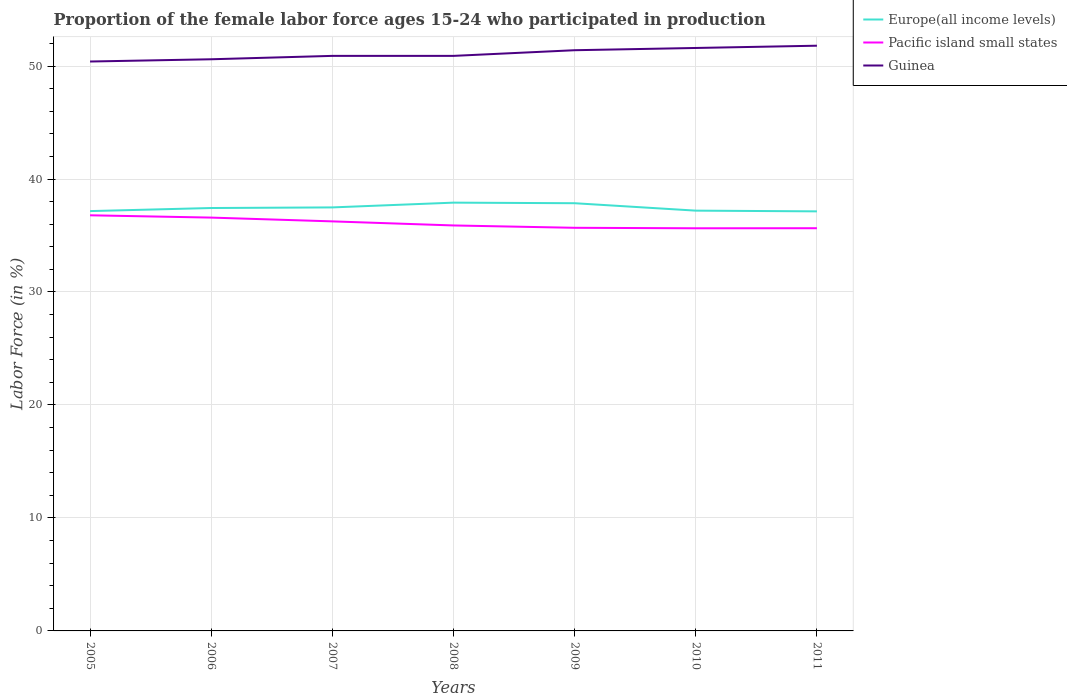How many different coloured lines are there?
Offer a very short reply. 3. Does the line corresponding to Guinea intersect with the line corresponding to Pacific island small states?
Make the answer very short. No. Is the number of lines equal to the number of legend labels?
Your answer should be very brief. Yes. Across all years, what is the maximum proportion of the female labor force who participated in production in Guinea?
Offer a terse response. 50.4. What is the total proportion of the female labor force who participated in production in Europe(all income levels) in the graph?
Provide a succinct answer. 0.71. What is the difference between the highest and the second highest proportion of the female labor force who participated in production in Guinea?
Offer a very short reply. 1.4. What is the difference between the highest and the lowest proportion of the female labor force who participated in production in Europe(all income levels)?
Ensure brevity in your answer.  3. How many lines are there?
Your answer should be very brief. 3. How many years are there in the graph?
Your answer should be very brief. 7. Are the values on the major ticks of Y-axis written in scientific E-notation?
Keep it short and to the point. No. Does the graph contain any zero values?
Provide a succinct answer. No. Does the graph contain grids?
Make the answer very short. Yes. How many legend labels are there?
Keep it short and to the point. 3. How are the legend labels stacked?
Offer a very short reply. Vertical. What is the title of the graph?
Provide a succinct answer. Proportion of the female labor force ages 15-24 who participated in production. Does "Cyprus" appear as one of the legend labels in the graph?
Give a very brief answer. No. What is the label or title of the X-axis?
Make the answer very short. Years. What is the label or title of the Y-axis?
Offer a very short reply. Labor Force (in %). What is the Labor Force (in %) of Europe(all income levels) in 2005?
Provide a succinct answer. 37.16. What is the Labor Force (in %) in Pacific island small states in 2005?
Your answer should be very brief. 36.79. What is the Labor Force (in %) of Guinea in 2005?
Give a very brief answer. 50.4. What is the Labor Force (in %) of Europe(all income levels) in 2006?
Provide a short and direct response. 37.43. What is the Labor Force (in %) in Pacific island small states in 2006?
Ensure brevity in your answer.  36.59. What is the Labor Force (in %) in Guinea in 2006?
Offer a very short reply. 50.6. What is the Labor Force (in %) in Europe(all income levels) in 2007?
Provide a succinct answer. 37.49. What is the Labor Force (in %) in Pacific island small states in 2007?
Ensure brevity in your answer.  36.25. What is the Labor Force (in %) in Guinea in 2007?
Offer a very short reply. 50.9. What is the Labor Force (in %) in Europe(all income levels) in 2008?
Offer a terse response. 37.91. What is the Labor Force (in %) of Pacific island small states in 2008?
Your answer should be very brief. 35.89. What is the Labor Force (in %) in Guinea in 2008?
Make the answer very short. 50.9. What is the Labor Force (in %) in Europe(all income levels) in 2009?
Provide a succinct answer. 37.86. What is the Labor Force (in %) of Pacific island small states in 2009?
Keep it short and to the point. 35.68. What is the Labor Force (in %) in Guinea in 2009?
Provide a short and direct response. 51.4. What is the Labor Force (in %) in Europe(all income levels) in 2010?
Keep it short and to the point. 37.2. What is the Labor Force (in %) of Pacific island small states in 2010?
Provide a succinct answer. 35.64. What is the Labor Force (in %) in Guinea in 2010?
Provide a short and direct response. 51.6. What is the Labor Force (in %) in Europe(all income levels) in 2011?
Give a very brief answer. 37.14. What is the Labor Force (in %) in Pacific island small states in 2011?
Offer a very short reply. 35.64. What is the Labor Force (in %) in Guinea in 2011?
Offer a very short reply. 51.8. Across all years, what is the maximum Labor Force (in %) of Europe(all income levels)?
Make the answer very short. 37.91. Across all years, what is the maximum Labor Force (in %) in Pacific island small states?
Keep it short and to the point. 36.79. Across all years, what is the maximum Labor Force (in %) of Guinea?
Give a very brief answer. 51.8. Across all years, what is the minimum Labor Force (in %) of Europe(all income levels)?
Offer a terse response. 37.14. Across all years, what is the minimum Labor Force (in %) in Pacific island small states?
Provide a short and direct response. 35.64. Across all years, what is the minimum Labor Force (in %) of Guinea?
Ensure brevity in your answer.  50.4. What is the total Labor Force (in %) in Europe(all income levels) in the graph?
Provide a succinct answer. 262.19. What is the total Labor Force (in %) in Pacific island small states in the graph?
Ensure brevity in your answer.  252.48. What is the total Labor Force (in %) of Guinea in the graph?
Provide a succinct answer. 357.6. What is the difference between the Labor Force (in %) of Europe(all income levels) in 2005 and that in 2006?
Your answer should be very brief. -0.27. What is the difference between the Labor Force (in %) of Pacific island small states in 2005 and that in 2006?
Make the answer very short. 0.2. What is the difference between the Labor Force (in %) in Guinea in 2005 and that in 2006?
Ensure brevity in your answer.  -0.2. What is the difference between the Labor Force (in %) in Europe(all income levels) in 2005 and that in 2007?
Provide a short and direct response. -0.33. What is the difference between the Labor Force (in %) of Pacific island small states in 2005 and that in 2007?
Offer a terse response. 0.54. What is the difference between the Labor Force (in %) in Guinea in 2005 and that in 2007?
Make the answer very short. -0.5. What is the difference between the Labor Force (in %) in Europe(all income levels) in 2005 and that in 2008?
Your answer should be very brief. -0.75. What is the difference between the Labor Force (in %) of Pacific island small states in 2005 and that in 2008?
Provide a succinct answer. 0.9. What is the difference between the Labor Force (in %) in Europe(all income levels) in 2005 and that in 2009?
Ensure brevity in your answer.  -0.7. What is the difference between the Labor Force (in %) in Pacific island small states in 2005 and that in 2009?
Make the answer very short. 1.11. What is the difference between the Labor Force (in %) in Europe(all income levels) in 2005 and that in 2010?
Give a very brief answer. -0.04. What is the difference between the Labor Force (in %) of Pacific island small states in 2005 and that in 2010?
Your answer should be compact. 1.15. What is the difference between the Labor Force (in %) of Europe(all income levels) in 2005 and that in 2011?
Give a very brief answer. 0.02. What is the difference between the Labor Force (in %) of Pacific island small states in 2005 and that in 2011?
Your response must be concise. 1.14. What is the difference between the Labor Force (in %) of Guinea in 2005 and that in 2011?
Your answer should be compact. -1.4. What is the difference between the Labor Force (in %) of Europe(all income levels) in 2006 and that in 2007?
Offer a very short reply. -0.05. What is the difference between the Labor Force (in %) in Pacific island small states in 2006 and that in 2007?
Keep it short and to the point. 0.33. What is the difference between the Labor Force (in %) in Europe(all income levels) in 2006 and that in 2008?
Your response must be concise. -0.48. What is the difference between the Labor Force (in %) in Pacific island small states in 2006 and that in 2008?
Offer a very short reply. 0.7. What is the difference between the Labor Force (in %) in Europe(all income levels) in 2006 and that in 2009?
Your answer should be compact. -0.43. What is the difference between the Labor Force (in %) in Pacific island small states in 2006 and that in 2009?
Provide a short and direct response. 0.9. What is the difference between the Labor Force (in %) of Europe(all income levels) in 2006 and that in 2010?
Make the answer very short. 0.23. What is the difference between the Labor Force (in %) in Pacific island small states in 2006 and that in 2010?
Offer a very short reply. 0.95. What is the difference between the Labor Force (in %) of Guinea in 2006 and that in 2010?
Give a very brief answer. -1. What is the difference between the Labor Force (in %) in Europe(all income levels) in 2006 and that in 2011?
Your response must be concise. 0.3. What is the difference between the Labor Force (in %) of Pacific island small states in 2006 and that in 2011?
Provide a succinct answer. 0.94. What is the difference between the Labor Force (in %) of Europe(all income levels) in 2007 and that in 2008?
Provide a short and direct response. -0.42. What is the difference between the Labor Force (in %) in Pacific island small states in 2007 and that in 2008?
Offer a very short reply. 0.36. What is the difference between the Labor Force (in %) of Guinea in 2007 and that in 2008?
Provide a succinct answer. 0. What is the difference between the Labor Force (in %) of Europe(all income levels) in 2007 and that in 2009?
Provide a succinct answer. -0.37. What is the difference between the Labor Force (in %) in Pacific island small states in 2007 and that in 2009?
Keep it short and to the point. 0.57. What is the difference between the Labor Force (in %) of Guinea in 2007 and that in 2009?
Give a very brief answer. -0.5. What is the difference between the Labor Force (in %) in Europe(all income levels) in 2007 and that in 2010?
Provide a succinct answer. 0.29. What is the difference between the Labor Force (in %) in Pacific island small states in 2007 and that in 2010?
Offer a very short reply. 0.61. What is the difference between the Labor Force (in %) in Guinea in 2007 and that in 2010?
Give a very brief answer. -0.7. What is the difference between the Labor Force (in %) of Europe(all income levels) in 2007 and that in 2011?
Give a very brief answer. 0.35. What is the difference between the Labor Force (in %) of Pacific island small states in 2007 and that in 2011?
Give a very brief answer. 0.61. What is the difference between the Labor Force (in %) of Guinea in 2007 and that in 2011?
Offer a terse response. -0.9. What is the difference between the Labor Force (in %) of Europe(all income levels) in 2008 and that in 2009?
Offer a very short reply. 0.05. What is the difference between the Labor Force (in %) of Pacific island small states in 2008 and that in 2009?
Offer a very short reply. 0.21. What is the difference between the Labor Force (in %) in Europe(all income levels) in 2008 and that in 2010?
Give a very brief answer. 0.71. What is the difference between the Labor Force (in %) in Pacific island small states in 2008 and that in 2010?
Ensure brevity in your answer.  0.25. What is the difference between the Labor Force (in %) in Europe(all income levels) in 2008 and that in 2011?
Give a very brief answer. 0.77. What is the difference between the Labor Force (in %) of Pacific island small states in 2008 and that in 2011?
Your answer should be compact. 0.25. What is the difference between the Labor Force (in %) in Guinea in 2008 and that in 2011?
Keep it short and to the point. -0.9. What is the difference between the Labor Force (in %) in Europe(all income levels) in 2009 and that in 2010?
Provide a short and direct response. 0.66. What is the difference between the Labor Force (in %) in Pacific island small states in 2009 and that in 2010?
Offer a terse response. 0.04. What is the difference between the Labor Force (in %) of Europe(all income levels) in 2009 and that in 2011?
Your answer should be very brief. 0.72. What is the difference between the Labor Force (in %) of Pacific island small states in 2009 and that in 2011?
Your answer should be compact. 0.04. What is the difference between the Labor Force (in %) of Europe(all income levels) in 2010 and that in 2011?
Make the answer very short. 0.06. What is the difference between the Labor Force (in %) in Pacific island small states in 2010 and that in 2011?
Provide a short and direct response. -0.01. What is the difference between the Labor Force (in %) in Guinea in 2010 and that in 2011?
Make the answer very short. -0.2. What is the difference between the Labor Force (in %) in Europe(all income levels) in 2005 and the Labor Force (in %) in Pacific island small states in 2006?
Provide a short and direct response. 0.58. What is the difference between the Labor Force (in %) of Europe(all income levels) in 2005 and the Labor Force (in %) of Guinea in 2006?
Provide a short and direct response. -13.44. What is the difference between the Labor Force (in %) in Pacific island small states in 2005 and the Labor Force (in %) in Guinea in 2006?
Make the answer very short. -13.81. What is the difference between the Labor Force (in %) of Europe(all income levels) in 2005 and the Labor Force (in %) of Pacific island small states in 2007?
Give a very brief answer. 0.91. What is the difference between the Labor Force (in %) of Europe(all income levels) in 2005 and the Labor Force (in %) of Guinea in 2007?
Make the answer very short. -13.74. What is the difference between the Labor Force (in %) of Pacific island small states in 2005 and the Labor Force (in %) of Guinea in 2007?
Keep it short and to the point. -14.11. What is the difference between the Labor Force (in %) in Europe(all income levels) in 2005 and the Labor Force (in %) in Pacific island small states in 2008?
Make the answer very short. 1.27. What is the difference between the Labor Force (in %) of Europe(all income levels) in 2005 and the Labor Force (in %) of Guinea in 2008?
Offer a terse response. -13.74. What is the difference between the Labor Force (in %) of Pacific island small states in 2005 and the Labor Force (in %) of Guinea in 2008?
Offer a terse response. -14.11. What is the difference between the Labor Force (in %) in Europe(all income levels) in 2005 and the Labor Force (in %) in Pacific island small states in 2009?
Offer a very short reply. 1.48. What is the difference between the Labor Force (in %) of Europe(all income levels) in 2005 and the Labor Force (in %) of Guinea in 2009?
Offer a very short reply. -14.24. What is the difference between the Labor Force (in %) in Pacific island small states in 2005 and the Labor Force (in %) in Guinea in 2009?
Your answer should be very brief. -14.61. What is the difference between the Labor Force (in %) in Europe(all income levels) in 2005 and the Labor Force (in %) in Pacific island small states in 2010?
Make the answer very short. 1.52. What is the difference between the Labor Force (in %) of Europe(all income levels) in 2005 and the Labor Force (in %) of Guinea in 2010?
Provide a succinct answer. -14.44. What is the difference between the Labor Force (in %) of Pacific island small states in 2005 and the Labor Force (in %) of Guinea in 2010?
Your answer should be compact. -14.81. What is the difference between the Labor Force (in %) of Europe(all income levels) in 2005 and the Labor Force (in %) of Pacific island small states in 2011?
Give a very brief answer. 1.52. What is the difference between the Labor Force (in %) in Europe(all income levels) in 2005 and the Labor Force (in %) in Guinea in 2011?
Make the answer very short. -14.64. What is the difference between the Labor Force (in %) of Pacific island small states in 2005 and the Labor Force (in %) of Guinea in 2011?
Provide a succinct answer. -15.01. What is the difference between the Labor Force (in %) of Europe(all income levels) in 2006 and the Labor Force (in %) of Pacific island small states in 2007?
Ensure brevity in your answer.  1.18. What is the difference between the Labor Force (in %) of Europe(all income levels) in 2006 and the Labor Force (in %) of Guinea in 2007?
Make the answer very short. -13.47. What is the difference between the Labor Force (in %) in Pacific island small states in 2006 and the Labor Force (in %) in Guinea in 2007?
Give a very brief answer. -14.31. What is the difference between the Labor Force (in %) in Europe(all income levels) in 2006 and the Labor Force (in %) in Pacific island small states in 2008?
Offer a very short reply. 1.54. What is the difference between the Labor Force (in %) of Europe(all income levels) in 2006 and the Labor Force (in %) of Guinea in 2008?
Make the answer very short. -13.47. What is the difference between the Labor Force (in %) in Pacific island small states in 2006 and the Labor Force (in %) in Guinea in 2008?
Provide a short and direct response. -14.31. What is the difference between the Labor Force (in %) of Europe(all income levels) in 2006 and the Labor Force (in %) of Pacific island small states in 2009?
Offer a terse response. 1.75. What is the difference between the Labor Force (in %) in Europe(all income levels) in 2006 and the Labor Force (in %) in Guinea in 2009?
Offer a very short reply. -13.97. What is the difference between the Labor Force (in %) in Pacific island small states in 2006 and the Labor Force (in %) in Guinea in 2009?
Keep it short and to the point. -14.81. What is the difference between the Labor Force (in %) of Europe(all income levels) in 2006 and the Labor Force (in %) of Pacific island small states in 2010?
Provide a short and direct response. 1.79. What is the difference between the Labor Force (in %) of Europe(all income levels) in 2006 and the Labor Force (in %) of Guinea in 2010?
Ensure brevity in your answer.  -14.17. What is the difference between the Labor Force (in %) of Pacific island small states in 2006 and the Labor Force (in %) of Guinea in 2010?
Give a very brief answer. -15.01. What is the difference between the Labor Force (in %) in Europe(all income levels) in 2006 and the Labor Force (in %) in Pacific island small states in 2011?
Make the answer very short. 1.79. What is the difference between the Labor Force (in %) in Europe(all income levels) in 2006 and the Labor Force (in %) in Guinea in 2011?
Your response must be concise. -14.37. What is the difference between the Labor Force (in %) in Pacific island small states in 2006 and the Labor Force (in %) in Guinea in 2011?
Make the answer very short. -15.21. What is the difference between the Labor Force (in %) in Europe(all income levels) in 2007 and the Labor Force (in %) in Pacific island small states in 2008?
Give a very brief answer. 1.6. What is the difference between the Labor Force (in %) in Europe(all income levels) in 2007 and the Labor Force (in %) in Guinea in 2008?
Your answer should be very brief. -13.41. What is the difference between the Labor Force (in %) in Pacific island small states in 2007 and the Labor Force (in %) in Guinea in 2008?
Your answer should be very brief. -14.65. What is the difference between the Labor Force (in %) in Europe(all income levels) in 2007 and the Labor Force (in %) in Pacific island small states in 2009?
Your answer should be very brief. 1.81. What is the difference between the Labor Force (in %) in Europe(all income levels) in 2007 and the Labor Force (in %) in Guinea in 2009?
Provide a succinct answer. -13.91. What is the difference between the Labor Force (in %) in Pacific island small states in 2007 and the Labor Force (in %) in Guinea in 2009?
Offer a terse response. -15.15. What is the difference between the Labor Force (in %) in Europe(all income levels) in 2007 and the Labor Force (in %) in Pacific island small states in 2010?
Make the answer very short. 1.85. What is the difference between the Labor Force (in %) in Europe(all income levels) in 2007 and the Labor Force (in %) in Guinea in 2010?
Make the answer very short. -14.11. What is the difference between the Labor Force (in %) in Pacific island small states in 2007 and the Labor Force (in %) in Guinea in 2010?
Provide a short and direct response. -15.35. What is the difference between the Labor Force (in %) of Europe(all income levels) in 2007 and the Labor Force (in %) of Pacific island small states in 2011?
Your answer should be compact. 1.84. What is the difference between the Labor Force (in %) of Europe(all income levels) in 2007 and the Labor Force (in %) of Guinea in 2011?
Keep it short and to the point. -14.31. What is the difference between the Labor Force (in %) of Pacific island small states in 2007 and the Labor Force (in %) of Guinea in 2011?
Offer a very short reply. -15.55. What is the difference between the Labor Force (in %) in Europe(all income levels) in 2008 and the Labor Force (in %) in Pacific island small states in 2009?
Your answer should be compact. 2.23. What is the difference between the Labor Force (in %) of Europe(all income levels) in 2008 and the Labor Force (in %) of Guinea in 2009?
Offer a very short reply. -13.49. What is the difference between the Labor Force (in %) in Pacific island small states in 2008 and the Labor Force (in %) in Guinea in 2009?
Give a very brief answer. -15.51. What is the difference between the Labor Force (in %) of Europe(all income levels) in 2008 and the Labor Force (in %) of Pacific island small states in 2010?
Make the answer very short. 2.27. What is the difference between the Labor Force (in %) in Europe(all income levels) in 2008 and the Labor Force (in %) in Guinea in 2010?
Provide a short and direct response. -13.69. What is the difference between the Labor Force (in %) in Pacific island small states in 2008 and the Labor Force (in %) in Guinea in 2010?
Keep it short and to the point. -15.71. What is the difference between the Labor Force (in %) of Europe(all income levels) in 2008 and the Labor Force (in %) of Pacific island small states in 2011?
Ensure brevity in your answer.  2.26. What is the difference between the Labor Force (in %) of Europe(all income levels) in 2008 and the Labor Force (in %) of Guinea in 2011?
Make the answer very short. -13.89. What is the difference between the Labor Force (in %) of Pacific island small states in 2008 and the Labor Force (in %) of Guinea in 2011?
Offer a terse response. -15.91. What is the difference between the Labor Force (in %) in Europe(all income levels) in 2009 and the Labor Force (in %) in Pacific island small states in 2010?
Provide a succinct answer. 2.22. What is the difference between the Labor Force (in %) in Europe(all income levels) in 2009 and the Labor Force (in %) in Guinea in 2010?
Give a very brief answer. -13.74. What is the difference between the Labor Force (in %) of Pacific island small states in 2009 and the Labor Force (in %) of Guinea in 2010?
Provide a short and direct response. -15.92. What is the difference between the Labor Force (in %) in Europe(all income levels) in 2009 and the Labor Force (in %) in Pacific island small states in 2011?
Your answer should be compact. 2.21. What is the difference between the Labor Force (in %) of Europe(all income levels) in 2009 and the Labor Force (in %) of Guinea in 2011?
Provide a short and direct response. -13.94. What is the difference between the Labor Force (in %) of Pacific island small states in 2009 and the Labor Force (in %) of Guinea in 2011?
Provide a short and direct response. -16.12. What is the difference between the Labor Force (in %) in Europe(all income levels) in 2010 and the Labor Force (in %) in Pacific island small states in 2011?
Provide a short and direct response. 1.56. What is the difference between the Labor Force (in %) of Europe(all income levels) in 2010 and the Labor Force (in %) of Guinea in 2011?
Give a very brief answer. -14.6. What is the difference between the Labor Force (in %) of Pacific island small states in 2010 and the Labor Force (in %) of Guinea in 2011?
Ensure brevity in your answer.  -16.16. What is the average Labor Force (in %) in Europe(all income levels) per year?
Give a very brief answer. 37.46. What is the average Labor Force (in %) of Pacific island small states per year?
Provide a short and direct response. 36.07. What is the average Labor Force (in %) of Guinea per year?
Offer a very short reply. 51.09. In the year 2005, what is the difference between the Labor Force (in %) of Europe(all income levels) and Labor Force (in %) of Pacific island small states?
Your response must be concise. 0.37. In the year 2005, what is the difference between the Labor Force (in %) in Europe(all income levels) and Labor Force (in %) in Guinea?
Keep it short and to the point. -13.24. In the year 2005, what is the difference between the Labor Force (in %) in Pacific island small states and Labor Force (in %) in Guinea?
Ensure brevity in your answer.  -13.61. In the year 2006, what is the difference between the Labor Force (in %) of Europe(all income levels) and Labor Force (in %) of Pacific island small states?
Your answer should be compact. 0.85. In the year 2006, what is the difference between the Labor Force (in %) of Europe(all income levels) and Labor Force (in %) of Guinea?
Ensure brevity in your answer.  -13.17. In the year 2006, what is the difference between the Labor Force (in %) in Pacific island small states and Labor Force (in %) in Guinea?
Provide a succinct answer. -14.01. In the year 2007, what is the difference between the Labor Force (in %) in Europe(all income levels) and Labor Force (in %) in Pacific island small states?
Your answer should be very brief. 1.24. In the year 2007, what is the difference between the Labor Force (in %) in Europe(all income levels) and Labor Force (in %) in Guinea?
Give a very brief answer. -13.41. In the year 2007, what is the difference between the Labor Force (in %) in Pacific island small states and Labor Force (in %) in Guinea?
Keep it short and to the point. -14.65. In the year 2008, what is the difference between the Labor Force (in %) in Europe(all income levels) and Labor Force (in %) in Pacific island small states?
Offer a terse response. 2.02. In the year 2008, what is the difference between the Labor Force (in %) of Europe(all income levels) and Labor Force (in %) of Guinea?
Ensure brevity in your answer.  -12.99. In the year 2008, what is the difference between the Labor Force (in %) of Pacific island small states and Labor Force (in %) of Guinea?
Make the answer very short. -15.01. In the year 2009, what is the difference between the Labor Force (in %) in Europe(all income levels) and Labor Force (in %) in Pacific island small states?
Ensure brevity in your answer.  2.18. In the year 2009, what is the difference between the Labor Force (in %) of Europe(all income levels) and Labor Force (in %) of Guinea?
Make the answer very short. -13.54. In the year 2009, what is the difference between the Labor Force (in %) in Pacific island small states and Labor Force (in %) in Guinea?
Offer a very short reply. -15.72. In the year 2010, what is the difference between the Labor Force (in %) in Europe(all income levels) and Labor Force (in %) in Pacific island small states?
Keep it short and to the point. 1.56. In the year 2010, what is the difference between the Labor Force (in %) in Europe(all income levels) and Labor Force (in %) in Guinea?
Provide a succinct answer. -14.4. In the year 2010, what is the difference between the Labor Force (in %) of Pacific island small states and Labor Force (in %) of Guinea?
Offer a very short reply. -15.96. In the year 2011, what is the difference between the Labor Force (in %) of Europe(all income levels) and Labor Force (in %) of Pacific island small states?
Keep it short and to the point. 1.49. In the year 2011, what is the difference between the Labor Force (in %) in Europe(all income levels) and Labor Force (in %) in Guinea?
Offer a very short reply. -14.66. In the year 2011, what is the difference between the Labor Force (in %) in Pacific island small states and Labor Force (in %) in Guinea?
Offer a terse response. -16.16. What is the ratio of the Labor Force (in %) of Europe(all income levels) in 2005 to that in 2006?
Your answer should be compact. 0.99. What is the ratio of the Labor Force (in %) of Pacific island small states in 2005 to that in 2006?
Your response must be concise. 1.01. What is the ratio of the Labor Force (in %) in Guinea in 2005 to that in 2006?
Make the answer very short. 1. What is the ratio of the Labor Force (in %) in Europe(all income levels) in 2005 to that in 2007?
Provide a succinct answer. 0.99. What is the ratio of the Labor Force (in %) in Pacific island small states in 2005 to that in 2007?
Keep it short and to the point. 1.01. What is the ratio of the Labor Force (in %) of Guinea in 2005 to that in 2007?
Give a very brief answer. 0.99. What is the ratio of the Labor Force (in %) of Europe(all income levels) in 2005 to that in 2008?
Your response must be concise. 0.98. What is the ratio of the Labor Force (in %) of Guinea in 2005 to that in 2008?
Make the answer very short. 0.99. What is the ratio of the Labor Force (in %) of Europe(all income levels) in 2005 to that in 2009?
Your answer should be compact. 0.98. What is the ratio of the Labor Force (in %) of Pacific island small states in 2005 to that in 2009?
Make the answer very short. 1.03. What is the ratio of the Labor Force (in %) of Guinea in 2005 to that in 2009?
Provide a succinct answer. 0.98. What is the ratio of the Labor Force (in %) of Europe(all income levels) in 2005 to that in 2010?
Keep it short and to the point. 1. What is the ratio of the Labor Force (in %) of Pacific island small states in 2005 to that in 2010?
Keep it short and to the point. 1.03. What is the ratio of the Labor Force (in %) in Guinea in 2005 to that in 2010?
Make the answer very short. 0.98. What is the ratio of the Labor Force (in %) of Pacific island small states in 2005 to that in 2011?
Your answer should be very brief. 1.03. What is the ratio of the Labor Force (in %) in Guinea in 2005 to that in 2011?
Your response must be concise. 0.97. What is the ratio of the Labor Force (in %) in Europe(all income levels) in 2006 to that in 2007?
Provide a succinct answer. 1. What is the ratio of the Labor Force (in %) in Pacific island small states in 2006 to that in 2007?
Give a very brief answer. 1.01. What is the ratio of the Labor Force (in %) in Guinea in 2006 to that in 2007?
Give a very brief answer. 0.99. What is the ratio of the Labor Force (in %) of Europe(all income levels) in 2006 to that in 2008?
Keep it short and to the point. 0.99. What is the ratio of the Labor Force (in %) in Pacific island small states in 2006 to that in 2008?
Your answer should be very brief. 1.02. What is the ratio of the Labor Force (in %) of Pacific island small states in 2006 to that in 2009?
Your answer should be compact. 1.03. What is the ratio of the Labor Force (in %) in Guinea in 2006 to that in 2009?
Offer a very short reply. 0.98. What is the ratio of the Labor Force (in %) in Europe(all income levels) in 2006 to that in 2010?
Make the answer very short. 1.01. What is the ratio of the Labor Force (in %) of Pacific island small states in 2006 to that in 2010?
Make the answer very short. 1.03. What is the ratio of the Labor Force (in %) of Guinea in 2006 to that in 2010?
Provide a short and direct response. 0.98. What is the ratio of the Labor Force (in %) in Pacific island small states in 2006 to that in 2011?
Provide a short and direct response. 1.03. What is the ratio of the Labor Force (in %) of Guinea in 2006 to that in 2011?
Make the answer very short. 0.98. What is the ratio of the Labor Force (in %) in Europe(all income levels) in 2007 to that in 2008?
Provide a short and direct response. 0.99. What is the ratio of the Labor Force (in %) in Pacific island small states in 2007 to that in 2008?
Your response must be concise. 1.01. What is the ratio of the Labor Force (in %) of Guinea in 2007 to that in 2008?
Your response must be concise. 1. What is the ratio of the Labor Force (in %) in Europe(all income levels) in 2007 to that in 2009?
Offer a terse response. 0.99. What is the ratio of the Labor Force (in %) of Pacific island small states in 2007 to that in 2009?
Provide a short and direct response. 1.02. What is the ratio of the Labor Force (in %) of Guinea in 2007 to that in 2009?
Offer a terse response. 0.99. What is the ratio of the Labor Force (in %) of Europe(all income levels) in 2007 to that in 2010?
Your answer should be very brief. 1.01. What is the ratio of the Labor Force (in %) in Pacific island small states in 2007 to that in 2010?
Offer a very short reply. 1.02. What is the ratio of the Labor Force (in %) of Guinea in 2007 to that in 2010?
Keep it short and to the point. 0.99. What is the ratio of the Labor Force (in %) of Europe(all income levels) in 2007 to that in 2011?
Offer a very short reply. 1.01. What is the ratio of the Labor Force (in %) of Guinea in 2007 to that in 2011?
Offer a very short reply. 0.98. What is the ratio of the Labor Force (in %) in Pacific island small states in 2008 to that in 2009?
Your answer should be compact. 1.01. What is the ratio of the Labor Force (in %) in Guinea in 2008 to that in 2009?
Your response must be concise. 0.99. What is the ratio of the Labor Force (in %) of Europe(all income levels) in 2008 to that in 2010?
Provide a succinct answer. 1.02. What is the ratio of the Labor Force (in %) in Pacific island small states in 2008 to that in 2010?
Offer a terse response. 1.01. What is the ratio of the Labor Force (in %) of Guinea in 2008 to that in 2010?
Your answer should be very brief. 0.99. What is the ratio of the Labor Force (in %) of Europe(all income levels) in 2008 to that in 2011?
Provide a short and direct response. 1.02. What is the ratio of the Labor Force (in %) of Pacific island small states in 2008 to that in 2011?
Ensure brevity in your answer.  1.01. What is the ratio of the Labor Force (in %) in Guinea in 2008 to that in 2011?
Make the answer very short. 0.98. What is the ratio of the Labor Force (in %) in Europe(all income levels) in 2009 to that in 2010?
Keep it short and to the point. 1.02. What is the ratio of the Labor Force (in %) of Pacific island small states in 2009 to that in 2010?
Keep it short and to the point. 1. What is the ratio of the Labor Force (in %) in Europe(all income levels) in 2009 to that in 2011?
Your response must be concise. 1.02. What is the ratio of the Labor Force (in %) in Europe(all income levels) in 2010 to that in 2011?
Make the answer very short. 1. What is the ratio of the Labor Force (in %) in Guinea in 2010 to that in 2011?
Keep it short and to the point. 1. What is the difference between the highest and the second highest Labor Force (in %) in Europe(all income levels)?
Make the answer very short. 0.05. What is the difference between the highest and the second highest Labor Force (in %) in Pacific island small states?
Make the answer very short. 0.2. What is the difference between the highest and the lowest Labor Force (in %) in Europe(all income levels)?
Provide a short and direct response. 0.77. What is the difference between the highest and the lowest Labor Force (in %) of Pacific island small states?
Your answer should be compact. 1.15. 